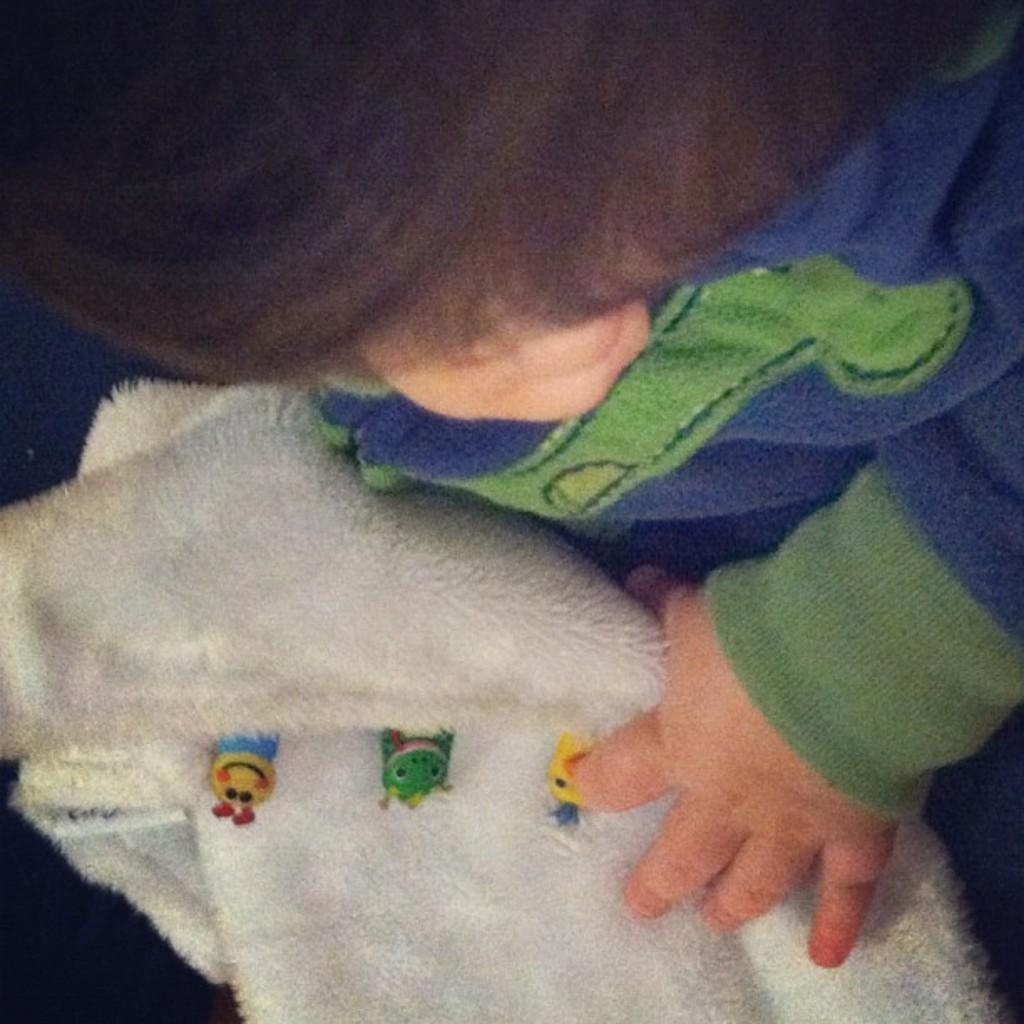What is the main subject of the image? The main subject of the image is a baby. What is the baby holding in the image? The baby is holding a white cloth. What type of soap is the baby using to wash the cloth in the image? There is no soap or washing activity present in the image. How does the baby show respect to the cloth in the image? There is no indication of respect or any specific action towards the cloth in the image. 